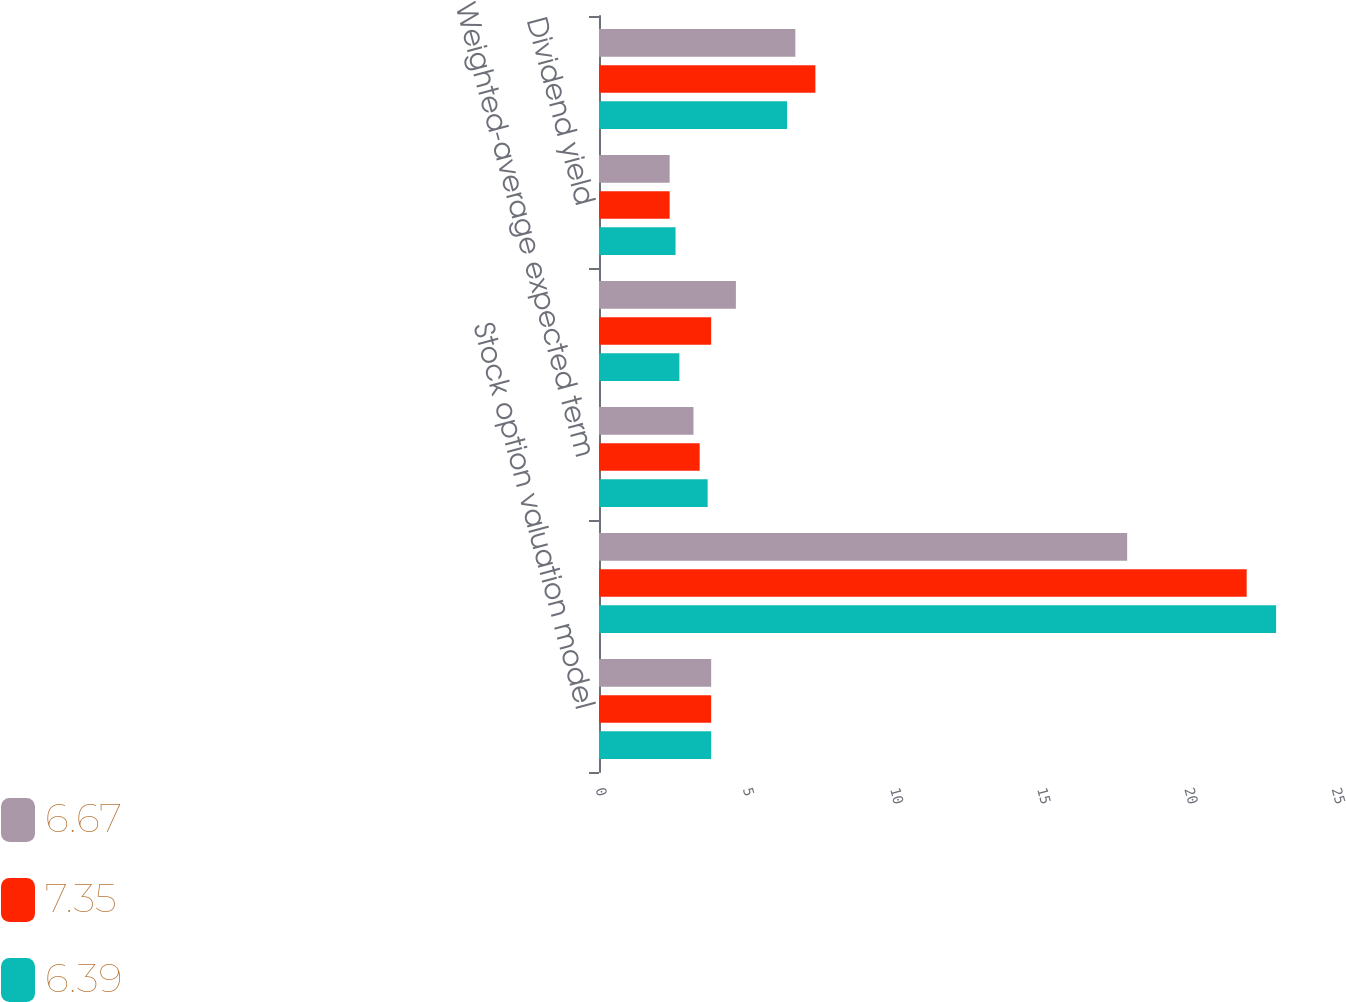<chart> <loc_0><loc_0><loc_500><loc_500><stacked_bar_chart><ecel><fcel>Stock option valuation model<fcel>Weighted-average expected<fcel>Weighted-average expected term<fcel>Weighted-average risk-free<fcel>Dividend yield<fcel>Weighed-average fair value of<nl><fcel>6.67<fcel>3.81<fcel>17.94<fcel>3.21<fcel>4.65<fcel>2.4<fcel>6.67<nl><fcel>7.35<fcel>3.81<fcel>22<fcel>3.42<fcel>3.81<fcel>2.4<fcel>7.35<nl><fcel>6.39<fcel>3.81<fcel>23<fcel>3.69<fcel>2.73<fcel>2.6<fcel>6.39<nl></chart> 